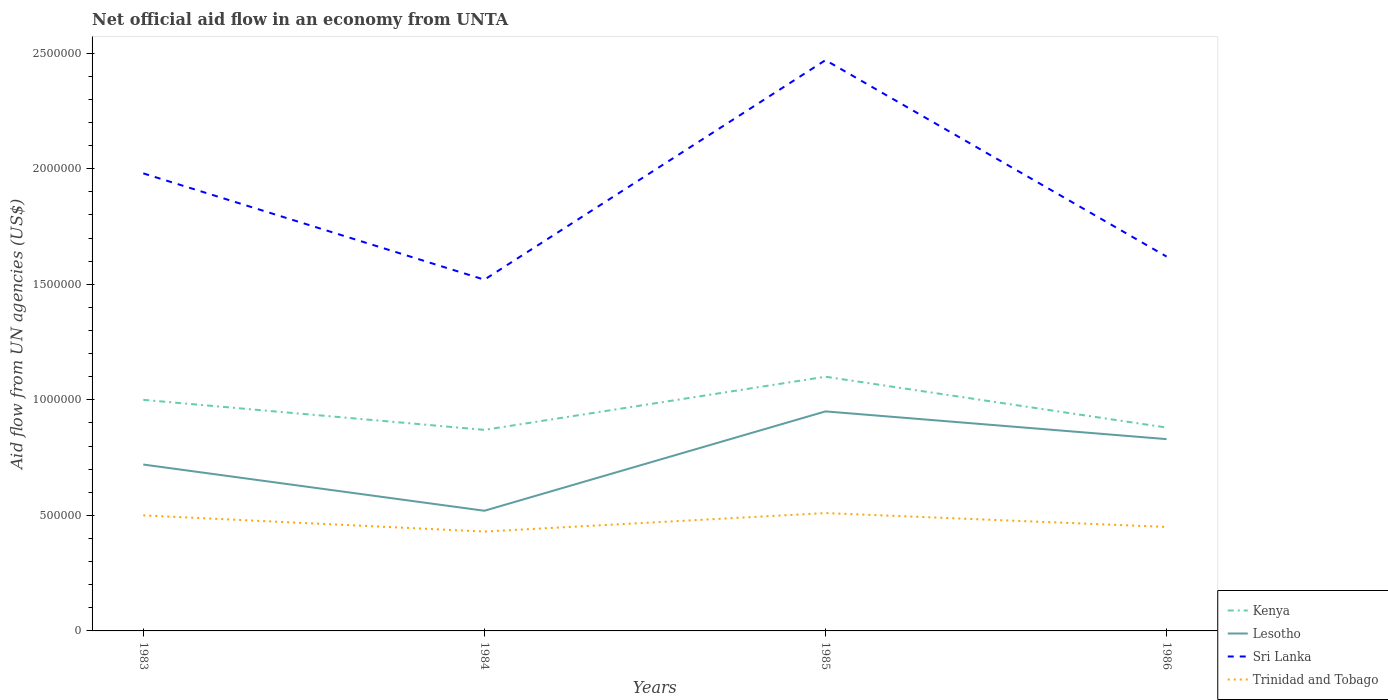Does the line corresponding to Sri Lanka intersect with the line corresponding to Kenya?
Ensure brevity in your answer.  No. Across all years, what is the maximum net official aid flow in Lesotho?
Ensure brevity in your answer.  5.20e+05. In which year was the net official aid flow in Trinidad and Tobago maximum?
Ensure brevity in your answer.  1984. What is the total net official aid flow in Lesotho in the graph?
Provide a succinct answer. -3.10e+05. What is the difference between the highest and the second highest net official aid flow in Sri Lanka?
Ensure brevity in your answer.  9.50e+05. Is the net official aid flow in Kenya strictly greater than the net official aid flow in Sri Lanka over the years?
Offer a very short reply. Yes. How many years are there in the graph?
Offer a terse response. 4. What is the difference between two consecutive major ticks on the Y-axis?
Your answer should be compact. 5.00e+05. How many legend labels are there?
Provide a succinct answer. 4. What is the title of the graph?
Offer a terse response. Net official aid flow in an economy from UNTA. Does "Cambodia" appear as one of the legend labels in the graph?
Give a very brief answer. No. What is the label or title of the Y-axis?
Offer a very short reply. Aid flow from UN agencies (US$). What is the Aid flow from UN agencies (US$) in Kenya in 1983?
Make the answer very short. 1.00e+06. What is the Aid flow from UN agencies (US$) in Lesotho in 1983?
Your answer should be compact. 7.20e+05. What is the Aid flow from UN agencies (US$) in Sri Lanka in 1983?
Make the answer very short. 1.98e+06. What is the Aid flow from UN agencies (US$) of Kenya in 1984?
Your answer should be compact. 8.70e+05. What is the Aid flow from UN agencies (US$) in Lesotho in 1984?
Give a very brief answer. 5.20e+05. What is the Aid flow from UN agencies (US$) in Sri Lanka in 1984?
Provide a short and direct response. 1.52e+06. What is the Aid flow from UN agencies (US$) in Trinidad and Tobago in 1984?
Your answer should be compact. 4.30e+05. What is the Aid flow from UN agencies (US$) of Kenya in 1985?
Ensure brevity in your answer.  1.10e+06. What is the Aid flow from UN agencies (US$) of Lesotho in 1985?
Offer a terse response. 9.50e+05. What is the Aid flow from UN agencies (US$) in Sri Lanka in 1985?
Provide a short and direct response. 2.47e+06. What is the Aid flow from UN agencies (US$) in Trinidad and Tobago in 1985?
Your response must be concise. 5.10e+05. What is the Aid flow from UN agencies (US$) in Kenya in 1986?
Give a very brief answer. 8.80e+05. What is the Aid flow from UN agencies (US$) of Lesotho in 1986?
Offer a terse response. 8.30e+05. What is the Aid flow from UN agencies (US$) in Sri Lanka in 1986?
Your answer should be very brief. 1.62e+06. What is the Aid flow from UN agencies (US$) in Trinidad and Tobago in 1986?
Provide a succinct answer. 4.50e+05. Across all years, what is the maximum Aid flow from UN agencies (US$) of Kenya?
Your response must be concise. 1.10e+06. Across all years, what is the maximum Aid flow from UN agencies (US$) of Lesotho?
Your answer should be very brief. 9.50e+05. Across all years, what is the maximum Aid flow from UN agencies (US$) of Sri Lanka?
Ensure brevity in your answer.  2.47e+06. Across all years, what is the maximum Aid flow from UN agencies (US$) of Trinidad and Tobago?
Your answer should be very brief. 5.10e+05. Across all years, what is the minimum Aid flow from UN agencies (US$) in Kenya?
Your answer should be very brief. 8.70e+05. Across all years, what is the minimum Aid flow from UN agencies (US$) in Lesotho?
Your answer should be very brief. 5.20e+05. Across all years, what is the minimum Aid flow from UN agencies (US$) in Sri Lanka?
Your response must be concise. 1.52e+06. Across all years, what is the minimum Aid flow from UN agencies (US$) in Trinidad and Tobago?
Make the answer very short. 4.30e+05. What is the total Aid flow from UN agencies (US$) in Kenya in the graph?
Keep it short and to the point. 3.85e+06. What is the total Aid flow from UN agencies (US$) of Lesotho in the graph?
Provide a short and direct response. 3.02e+06. What is the total Aid flow from UN agencies (US$) of Sri Lanka in the graph?
Ensure brevity in your answer.  7.59e+06. What is the total Aid flow from UN agencies (US$) of Trinidad and Tobago in the graph?
Offer a terse response. 1.89e+06. What is the difference between the Aid flow from UN agencies (US$) in Kenya in 1983 and that in 1984?
Your answer should be very brief. 1.30e+05. What is the difference between the Aid flow from UN agencies (US$) of Lesotho in 1983 and that in 1984?
Keep it short and to the point. 2.00e+05. What is the difference between the Aid flow from UN agencies (US$) of Kenya in 1983 and that in 1985?
Give a very brief answer. -1.00e+05. What is the difference between the Aid flow from UN agencies (US$) in Lesotho in 1983 and that in 1985?
Keep it short and to the point. -2.30e+05. What is the difference between the Aid flow from UN agencies (US$) in Sri Lanka in 1983 and that in 1985?
Make the answer very short. -4.90e+05. What is the difference between the Aid flow from UN agencies (US$) of Trinidad and Tobago in 1983 and that in 1985?
Provide a short and direct response. -10000. What is the difference between the Aid flow from UN agencies (US$) in Lesotho in 1983 and that in 1986?
Offer a terse response. -1.10e+05. What is the difference between the Aid flow from UN agencies (US$) in Lesotho in 1984 and that in 1985?
Your response must be concise. -4.30e+05. What is the difference between the Aid flow from UN agencies (US$) in Sri Lanka in 1984 and that in 1985?
Offer a terse response. -9.50e+05. What is the difference between the Aid flow from UN agencies (US$) in Trinidad and Tobago in 1984 and that in 1985?
Your response must be concise. -8.00e+04. What is the difference between the Aid flow from UN agencies (US$) in Kenya in 1984 and that in 1986?
Offer a very short reply. -10000. What is the difference between the Aid flow from UN agencies (US$) in Lesotho in 1984 and that in 1986?
Your answer should be compact. -3.10e+05. What is the difference between the Aid flow from UN agencies (US$) of Kenya in 1985 and that in 1986?
Keep it short and to the point. 2.20e+05. What is the difference between the Aid flow from UN agencies (US$) of Lesotho in 1985 and that in 1986?
Give a very brief answer. 1.20e+05. What is the difference between the Aid flow from UN agencies (US$) of Sri Lanka in 1985 and that in 1986?
Make the answer very short. 8.50e+05. What is the difference between the Aid flow from UN agencies (US$) of Kenya in 1983 and the Aid flow from UN agencies (US$) of Sri Lanka in 1984?
Keep it short and to the point. -5.20e+05. What is the difference between the Aid flow from UN agencies (US$) of Kenya in 1983 and the Aid flow from UN agencies (US$) of Trinidad and Tobago in 1984?
Your response must be concise. 5.70e+05. What is the difference between the Aid flow from UN agencies (US$) in Lesotho in 1983 and the Aid flow from UN agencies (US$) in Sri Lanka in 1984?
Your response must be concise. -8.00e+05. What is the difference between the Aid flow from UN agencies (US$) in Lesotho in 1983 and the Aid flow from UN agencies (US$) in Trinidad and Tobago in 1984?
Your answer should be compact. 2.90e+05. What is the difference between the Aid flow from UN agencies (US$) of Sri Lanka in 1983 and the Aid flow from UN agencies (US$) of Trinidad and Tobago in 1984?
Your response must be concise. 1.55e+06. What is the difference between the Aid flow from UN agencies (US$) of Kenya in 1983 and the Aid flow from UN agencies (US$) of Lesotho in 1985?
Provide a succinct answer. 5.00e+04. What is the difference between the Aid flow from UN agencies (US$) in Kenya in 1983 and the Aid flow from UN agencies (US$) in Sri Lanka in 1985?
Your answer should be very brief. -1.47e+06. What is the difference between the Aid flow from UN agencies (US$) of Lesotho in 1983 and the Aid flow from UN agencies (US$) of Sri Lanka in 1985?
Keep it short and to the point. -1.75e+06. What is the difference between the Aid flow from UN agencies (US$) of Lesotho in 1983 and the Aid flow from UN agencies (US$) of Trinidad and Tobago in 1985?
Provide a succinct answer. 2.10e+05. What is the difference between the Aid flow from UN agencies (US$) in Sri Lanka in 1983 and the Aid flow from UN agencies (US$) in Trinidad and Tobago in 1985?
Give a very brief answer. 1.47e+06. What is the difference between the Aid flow from UN agencies (US$) of Kenya in 1983 and the Aid flow from UN agencies (US$) of Lesotho in 1986?
Offer a terse response. 1.70e+05. What is the difference between the Aid flow from UN agencies (US$) in Kenya in 1983 and the Aid flow from UN agencies (US$) in Sri Lanka in 1986?
Offer a very short reply. -6.20e+05. What is the difference between the Aid flow from UN agencies (US$) in Kenya in 1983 and the Aid flow from UN agencies (US$) in Trinidad and Tobago in 1986?
Your answer should be compact. 5.50e+05. What is the difference between the Aid flow from UN agencies (US$) of Lesotho in 1983 and the Aid flow from UN agencies (US$) of Sri Lanka in 1986?
Ensure brevity in your answer.  -9.00e+05. What is the difference between the Aid flow from UN agencies (US$) of Sri Lanka in 1983 and the Aid flow from UN agencies (US$) of Trinidad and Tobago in 1986?
Make the answer very short. 1.53e+06. What is the difference between the Aid flow from UN agencies (US$) in Kenya in 1984 and the Aid flow from UN agencies (US$) in Lesotho in 1985?
Your answer should be very brief. -8.00e+04. What is the difference between the Aid flow from UN agencies (US$) in Kenya in 1984 and the Aid flow from UN agencies (US$) in Sri Lanka in 1985?
Ensure brevity in your answer.  -1.60e+06. What is the difference between the Aid flow from UN agencies (US$) of Kenya in 1984 and the Aid flow from UN agencies (US$) of Trinidad and Tobago in 1985?
Provide a short and direct response. 3.60e+05. What is the difference between the Aid flow from UN agencies (US$) in Lesotho in 1984 and the Aid flow from UN agencies (US$) in Sri Lanka in 1985?
Give a very brief answer. -1.95e+06. What is the difference between the Aid flow from UN agencies (US$) of Lesotho in 1984 and the Aid flow from UN agencies (US$) of Trinidad and Tobago in 1985?
Your response must be concise. 10000. What is the difference between the Aid flow from UN agencies (US$) of Sri Lanka in 1984 and the Aid flow from UN agencies (US$) of Trinidad and Tobago in 1985?
Offer a very short reply. 1.01e+06. What is the difference between the Aid flow from UN agencies (US$) in Kenya in 1984 and the Aid flow from UN agencies (US$) in Lesotho in 1986?
Your response must be concise. 4.00e+04. What is the difference between the Aid flow from UN agencies (US$) of Kenya in 1984 and the Aid flow from UN agencies (US$) of Sri Lanka in 1986?
Keep it short and to the point. -7.50e+05. What is the difference between the Aid flow from UN agencies (US$) in Lesotho in 1984 and the Aid flow from UN agencies (US$) in Sri Lanka in 1986?
Your response must be concise. -1.10e+06. What is the difference between the Aid flow from UN agencies (US$) of Lesotho in 1984 and the Aid flow from UN agencies (US$) of Trinidad and Tobago in 1986?
Ensure brevity in your answer.  7.00e+04. What is the difference between the Aid flow from UN agencies (US$) in Sri Lanka in 1984 and the Aid flow from UN agencies (US$) in Trinidad and Tobago in 1986?
Make the answer very short. 1.07e+06. What is the difference between the Aid flow from UN agencies (US$) of Kenya in 1985 and the Aid flow from UN agencies (US$) of Sri Lanka in 1986?
Ensure brevity in your answer.  -5.20e+05. What is the difference between the Aid flow from UN agencies (US$) in Kenya in 1985 and the Aid flow from UN agencies (US$) in Trinidad and Tobago in 1986?
Your response must be concise. 6.50e+05. What is the difference between the Aid flow from UN agencies (US$) of Lesotho in 1985 and the Aid flow from UN agencies (US$) of Sri Lanka in 1986?
Your response must be concise. -6.70e+05. What is the difference between the Aid flow from UN agencies (US$) in Sri Lanka in 1985 and the Aid flow from UN agencies (US$) in Trinidad and Tobago in 1986?
Ensure brevity in your answer.  2.02e+06. What is the average Aid flow from UN agencies (US$) of Kenya per year?
Make the answer very short. 9.62e+05. What is the average Aid flow from UN agencies (US$) in Lesotho per year?
Give a very brief answer. 7.55e+05. What is the average Aid flow from UN agencies (US$) in Sri Lanka per year?
Provide a succinct answer. 1.90e+06. What is the average Aid flow from UN agencies (US$) of Trinidad and Tobago per year?
Your response must be concise. 4.72e+05. In the year 1983, what is the difference between the Aid flow from UN agencies (US$) in Kenya and Aid flow from UN agencies (US$) in Lesotho?
Provide a succinct answer. 2.80e+05. In the year 1983, what is the difference between the Aid flow from UN agencies (US$) of Kenya and Aid flow from UN agencies (US$) of Sri Lanka?
Your response must be concise. -9.80e+05. In the year 1983, what is the difference between the Aid flow from UN agencies (US$) in Lesotho and Aid flow from UN agencies (US$) in Sri Lanka?
Ensure brevity in your answer.  -1.26e+06. In the year 1983, what is the difference between the Aid flow from UN agencies (US$) in Sri Lanka and Aid flow from UN agencies (US$) in Trinidad and Tobago?
Ensure brevity in your answer.  1.48e+06. In the year 1984, what is the difference between the Aid flow from UN agencies (US$) of Kenya and Aid flow from UN agencies (US$) of Lesotho?
Keep it short and to the point. 3.50e+05. In the year 1984, what is the difference between the Aid flow from UN agencies (US$) in Kenya and Aid flow from UN agencies (US$) in Sri Lanka?
Make the answer very short. -6.50e+05. In the year 1984, what is the difference between the Aid flow from UN agencies (US$) of Kenya and Aid flow from UN agencies (US$) of Trinidad and Tobago?
Offer a very short reply. 4.40e+05. In the year 1984, what is the difference between the Aid flow from UN agencies (US$) of Lesotho and Aid flow from UN agencies (US$) of Sri Lanka?
Provide a short and direct response. -1.00e+06. In the year 1984, what is the difference between the Aid flow from UN agencies (US$) of Lesotho and Aid flow from UN agencies (US$) of Trinidad and Tobago?
Your answer should be very brief. 9.00e+04. In the year 1984, what is the difference between the Aid flow from UN agencies (US$) of Sri Lanka and Aid flow from UN agencies (US$) of Trinidad and Tobago?
Give a very brief answer. 1.09e+06. In the year 1985, what is the difference between the Aid flow from UN agencies (US$) in Kenya and Aid flow from UN agencies (US$) in Lesotho?
Offer a terse response. 1.50e+05. In the year 1985, what is the difference between the Aid flow from UN agencies (US$) of Kenya and Aid flow from UN agencies (US$) of Sri Lanka?
Provide a short and direct response. -1.37e+06. In the year 1985, what is the difference between the Aid flow from UN agencies (US$) of Kenya and Aid flow from UN agencies (US$) of Trinidad and Tobago?
Ensure brevity in your answer.  5.90e+05. In the year 1985, what is the difference between the Aid flow from UN agencies (US$) of Lesotho and Aid flow from UN agencies (US$) of Sri Lanka?
Ensure brevity in your answer.  -1.52e+06. In the year 1985, what is the difference between the Aid flow from UN agencies (US$) of Sri Lanka and Aid flow from UN agencies (US$) of Trinidad and Tobago?
Ensure brevity in your answer.  1.96e+06. In the year 1986, what is the difference between the Aid flow from UN agencies (US$) of Kenya and Aid flow from UN agencies (US$) of Sri Lanka?
Ensure brevity in your answer.  -7.40e+05. In the year 1986, what is the difference between the Aid flow from UN agencies (US$) of Lesotho and Aid flow from UN agencies (US$) of Sri Lanka?
Your answer should be very brief. -7.90e+05. In the year 1986, what is the difference between the Aid flow from UN agencies (US$) of Lesotho and Aid flow from UN agencies (US$) of Trinidad and Tobago?
Your answer should be compact. 3.80e+05. In the year 1986, what is the difference between the Aid flow from UN agencies (US$) in Sri Lanka and Aid flow from UN agencies (US$) in Trinidad and Tobago?
Your answer should be very brief. 1.17e+06. What is the ratio of the Aid flow from UN agencies (US$) in Kenya in 1983 to that in 1984?
Provide a succinct answer. 1.15. What is the ratio of the Aid flow from UN agencies (US$) of Lesotho in 1983 to that in 1984?
Make the answer very short. 1.38. What is the ratio of the Aid flow from UN agencies (US$) of Sri Lanka in 1983 to that in 1984?
Ensure brevity in your answer.  1.3. What is the ratio of the Aid flow from UN agencies (US$) in Trinidad and Tobago in 1983 to that in 1984?
Ensure brevity in your answer.  1.16. What is the ratio of the Aid flow from UN agencies (US$) in Kenya in 1983 to that in 1985?
Your answer should be compact. 0.91. What is the ratio of the Aid flow from UN agencies (US$) in Lesotho in 1983 to that in 1985?
Make the answer very short. 0.76. What is the ratio of the Aid flow from UN agencies (US$) of Sri Lanka in 1983 to that in 1985?
Your answer should be compact. 0.8. What is the ratio of the Aid flow from UN agencies (US$) of Trinidad and Tobago in 1983 to that in 1985?
Your answer should be compact. 0.98. What is the ratio of the Aid flow from UN agencies (US$) of Kenya in 1983 to that in 1986?
Your response must be concise. 1.14. What is the ratio of the Aid flow from UN agencies (US$) of Lesotho in 1983 to that in 1986?
Provide a succinct answer. 0.87. What is the ratio of the Aid flow from UN agencies (US$) in Sri Lanka in 1983 to that in 1986?
Keep it short and to the point. 1.22. What is the ratio of the Aid flow from UN agencies (US$) in Kenya in 1984 to that in 1985?
Make the answer very short. 0.79. What is the ratio of the Aid flow from UN agencies (US$) in Lesotho in 1984 to that in 1985?
Ensure brevity in your answer.  0.55. What is the ratio of the Aid flow from UN agencies (US$) of Sri Lanka in 1984 to that in 1985?
Provide a short and direct response. 0.62. What is the ratio of the Aid flow from UN agencies (US$) in Trinidad and Tobago in 1984 to that in 1985?
Give a very brief answer. 0.84. What is the ratio of the Aid flow from UN agencies (US$) of Lesotho in 1984 to that in 1986?
Make the answer very short. 0.63. What is the ratio of the Aid flow from UN agencies (US$) in Sri Lanka in 1984 to that in 1986?
Provide a succinct answer. 0.94. What is the ratio of the Aid flow from UN agencies (US$) in Trinidad and Tobago in 1984 to that in 1986?
Keep it short and to the point. 0.96. What is the ratio of the Aid flow from UN agencies (US$) of Lesotho in 1985 to that in 1986?
Offer a very short reply. 1.14. What is the ratio of the Aid flow from UN agencies (US$) of Sri Lanka in 1985 to that in 1986?
Your answer should be very brief. 1.52. What is the ratio of the Aid flow from UN agencies (US$) of Trinidad and Tobago in 1985 to that in 1986?
Provide a short and direct response. 1.13. What is the difference between the highest and the lowest Aid flow from UN agencies (US$) in Kenya?
Your response must be concise. 2.30e+05. What is the difference between the highest and the lowest Aid flow from UN agencies (US$) in Sri Lanka?
Give a very brief answer. 9.50e+05. 